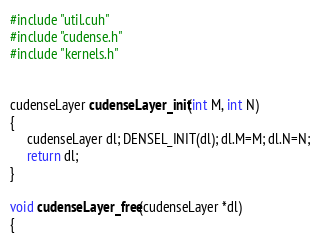Convert code to text. <code><loc_0><loc_0><loc_500><loc_500><_Cuda_>#include "util.cuh"
#include "cudense.h"
#include "kernels.h"


cudenseLayer cudenseLayer_init(int M, int N)
{
     cudenseLayer dl; DENSEL_INIT(dl); dl.M=M; dl.N=N;
     return dl;
}

void cudenseLayer_free(cudenseLayer *dl)
{</code> 